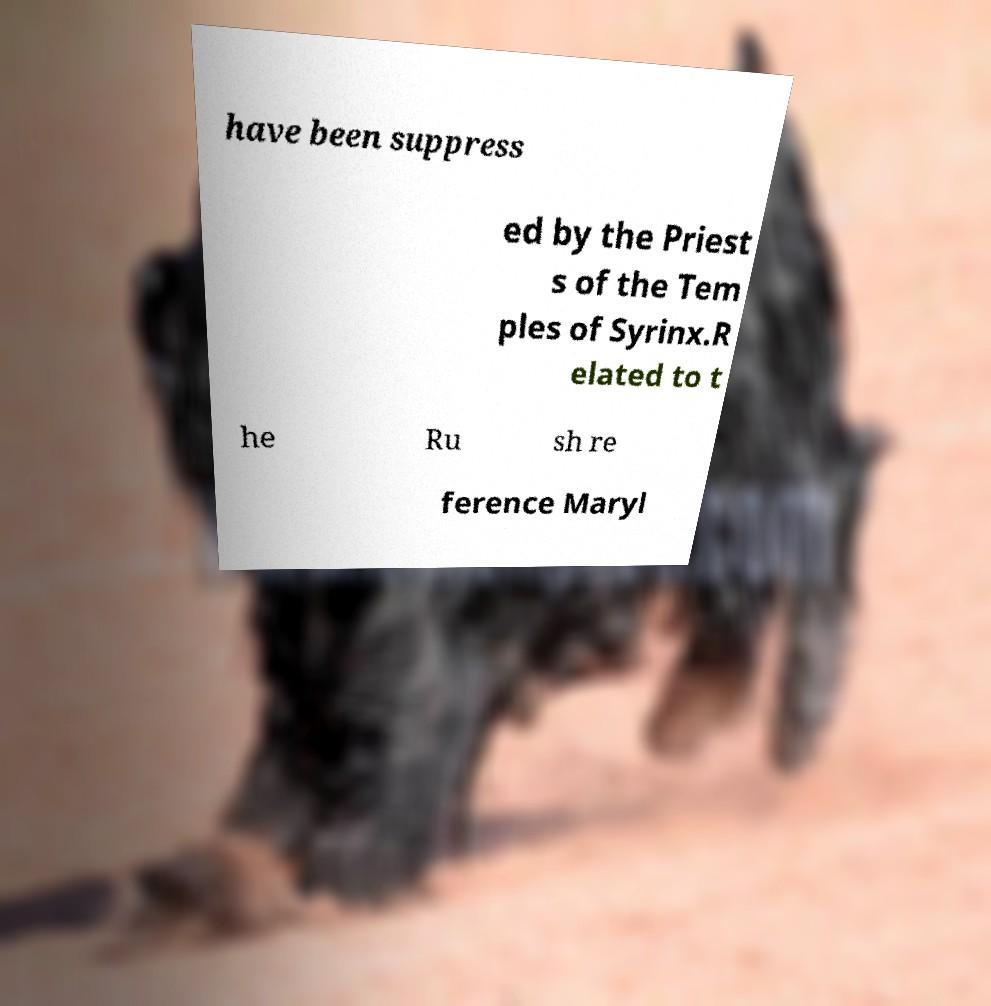Could you assist in decoding the text presented in this image and type it out clearly? have been suppress ed by the Priest s of the Tem ples of Syrinx.R elated to t he Ru sh re ference Maryl 